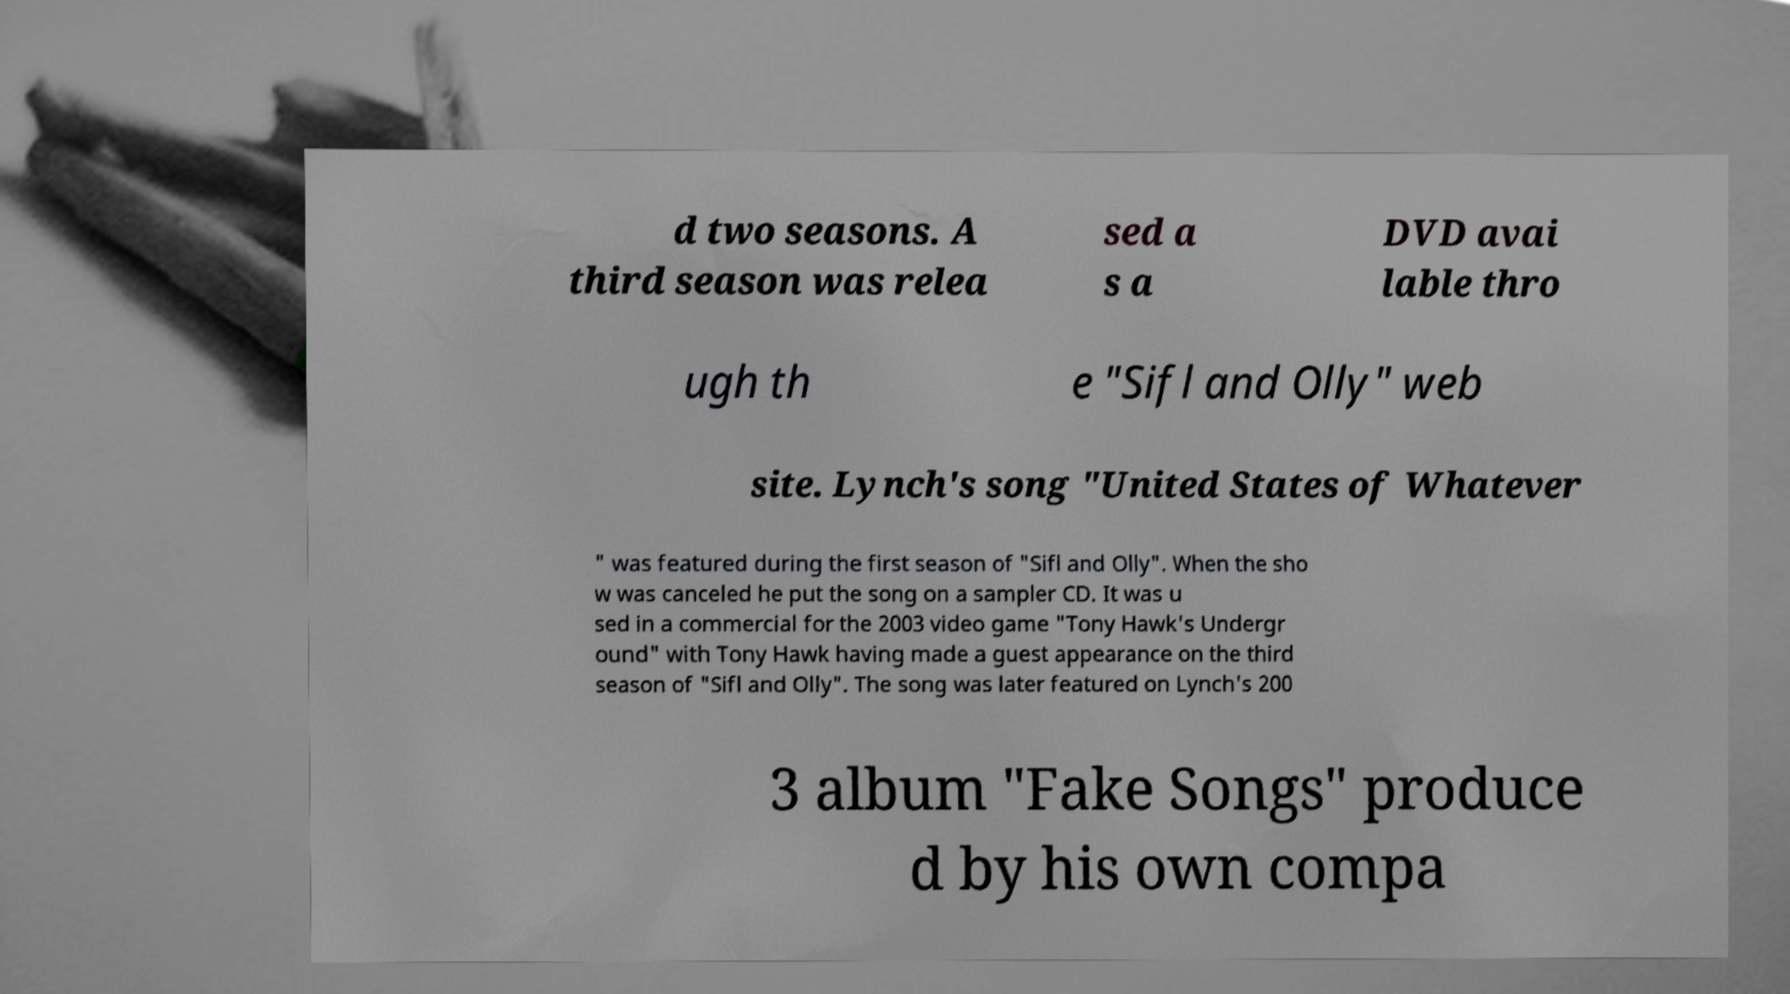Please read and relay the text visible in this image. What does it say? d two seasons. A third season was relea sed a s a DVD avai lable thro ugh th e "Sifl and Olly" web site. Lynch's song "United States of Whatever " was featured during the first season of "Sifl and Olly". When the sho w was canceled he put the song on a sampler CD. It was u sed in a commercial for the 2003 video game "Tony Hawk's Undergr ound" with Tony Hawk having made a guest appearance on the third season of "Sifl and Olly". The song was later featured on Lynch's 200 3 album "Fake Songs" produce d by his own compa 